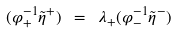<formula> <loc_0><loc_0><loc_500><loc_500>( \varphi _ { + } ^ { - 1 } \tilde { \eta } ^ { + } ) \ = \ \lambda _ { + } ( \varphi _ { - } ^ { - 1 } \tilde { \eta } ^ { - } )</formula> 